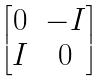Convert formula to latex. <formula><loc_0><loc_0><loc_500><loc_500>\begin{bmatrix} 0 & - I \\ I & 0 \end{bmatrix}</formula> 